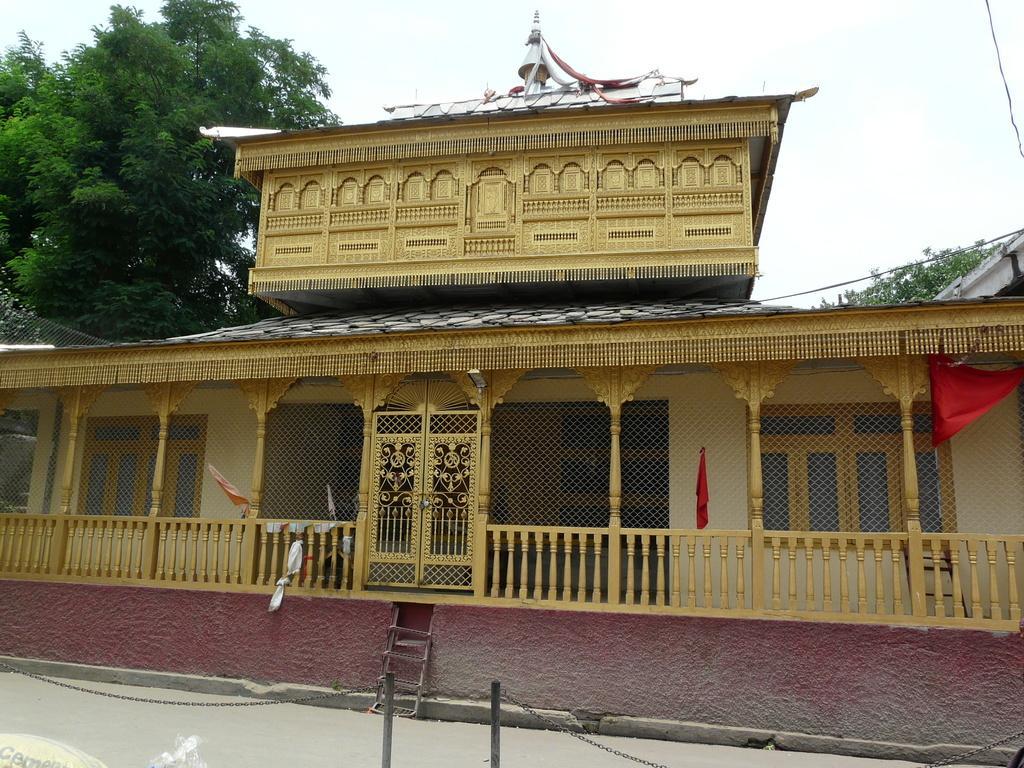Please provide a concise description of this image. In this picture there is shrine in the center of the image and there is boundary at the bottom side of the image, there are trees in the background area of the image. 